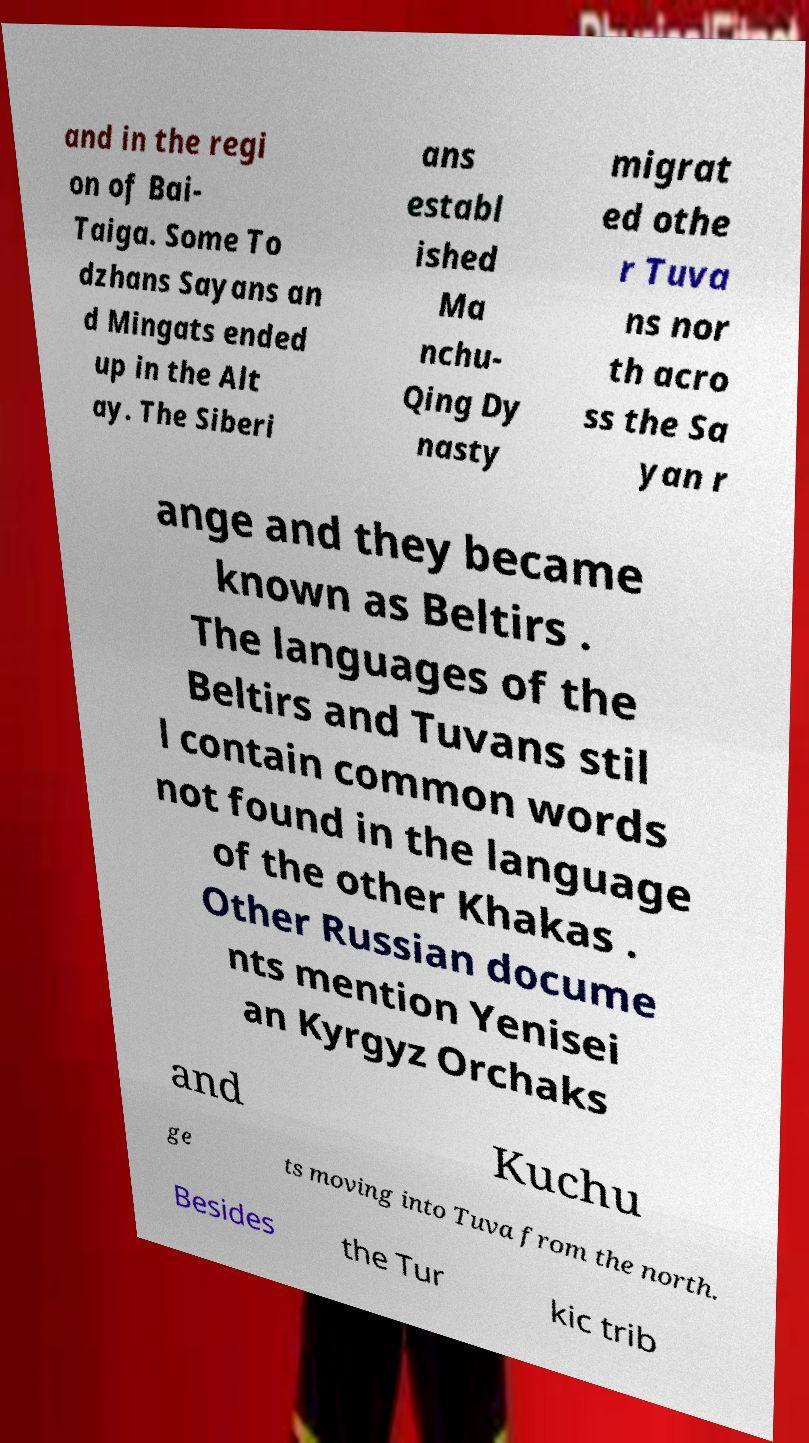Please identify and transcribe the text found in this image. and in the regi on of Bai- Taiga. Some To dzhans Sayans an d Mingats ended up in the Alt ay. The Siberi ans establ ished Ma nchu- Qing Dy nasty migrat ed othe r Tuva ns nor th acro ss the Sa yan r ange and they became known as Beltirs . The languages of the Beltirs and Tuvans stil l contain common words not found in the language of the other Khakas . Other Russian docume nts mention Yenisei an Kyrgyz Orchaks and Kuchu ge ts moving into Tuva from the north. Besides the Tur kic trib 